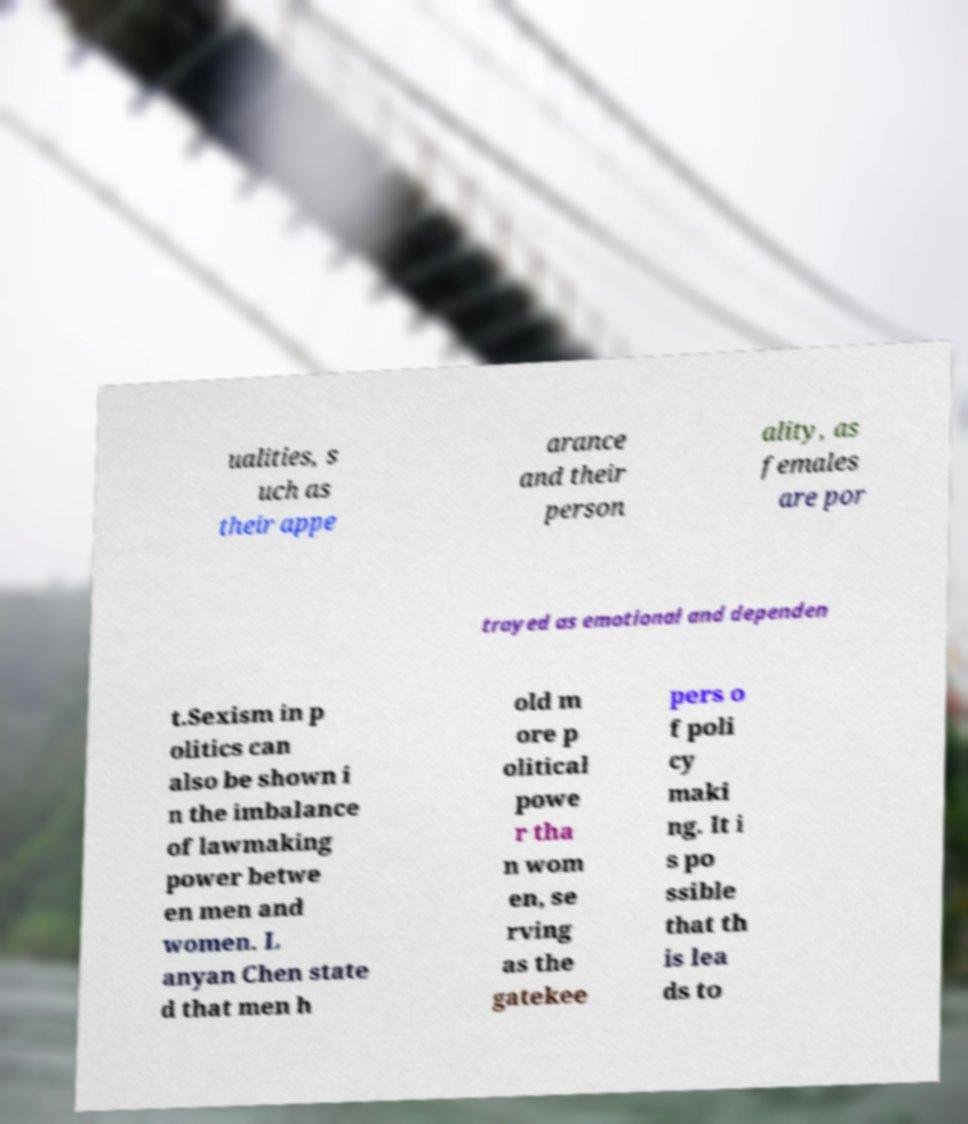Please identify and transcribe the text found in this image. ualities, s uch as their appe arance and their person ality, as females are por trayed as emotional and dependen t.Sexism in p olitics can also be shown i n the imbalance of lawmaking power betwe en men and women. L anyan Chen state d that men h old m ore p olitical powe r tha n wom en, se rving as the gatekee pers o f poli cy maki ng. It i s po ssible that th is lea ds to 